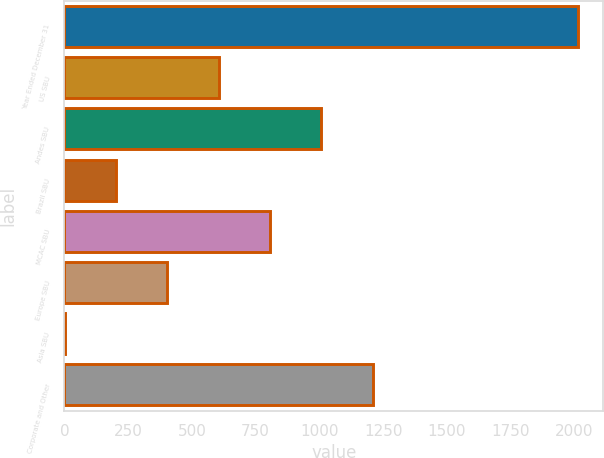Convert chart to OTSL. <chart><loc_0><loc_0><loc_500><loc_500><bar_chart><fcel>Year Ended December 31<fcel>US SBU<fcel>Andes SBU<fcel>Brazil SBU<fcel>MCAC SBU<fcel>Europe SBU<fcel>Asia SBU<fcel>Corporate and Other<nl><fcel>2013<fcel>605.3<fcel>1007.5<fcel>203.1<fcel>806.4<fcel>404.2<fcel>2<fcel>1208.6<nl></chart> 